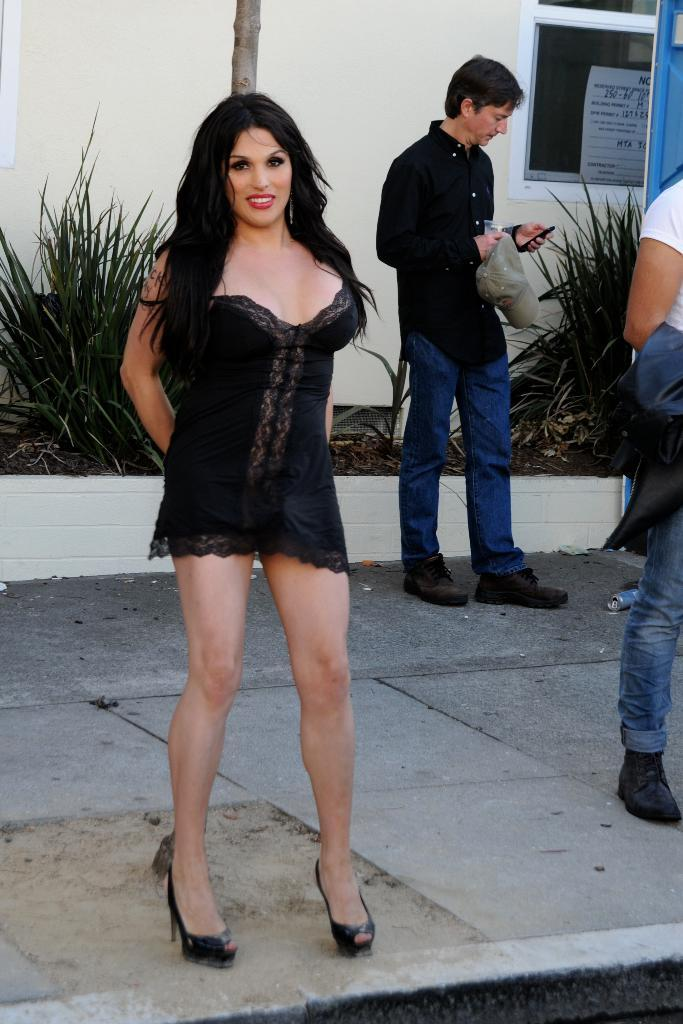How many people are in the image? There are two people in the image, a woman and a man. What are the people in the image doing? They are standing on the ground. What can be seen in the background of the image? There is a wall, a window, plants, and other objects in the background of the image. What type of stone is being exchanged between the two people in the image? There is no stone or exchange of any kind depicted in the image. 